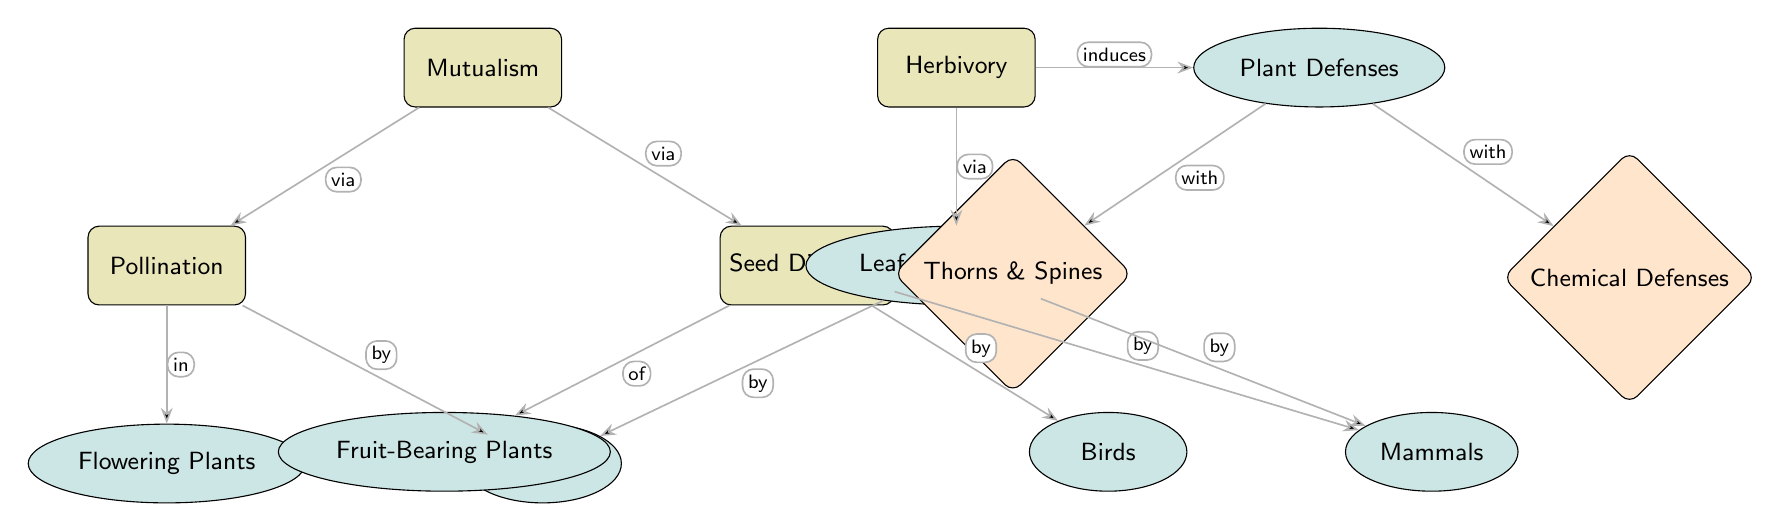what are the main interactions depicted in the diagram? The diagram shows two main interactions: mutualism (pollination and seed dispersal) and herbivory. These are identified as the main nodes at the top level.
Answer: Mutualism and Herbivory how many secondary nodes are there? Counting the secondary nodes, there are six: flowering plants, insects, fruit-bearing plants, birds, mammals, and leaf consumption.
Answer: Six which node is related to both pollination and insects? The node directly related to both pollination and insects is 'flowering plants', which connects pollination with insects in the diagram.
Answer: Flowering Plants what does herbivory induce? The diagram indicates that herbivory induces plant defenses, showing a direct relationship from herbivory to plant defenses.
Answer: Plant Defenses which secondary node is linked to leaf consumption by insects? The secondary node linked to leaf consumption by insects is directly indicated as being leaf consumption, which is part of the herbivory section.
Answer: Leaf Consumption describe the relationship between plant defenses and chemical defenses? The relationship is that plant defenses are applied with chemical defenses, indicating an interactive process where chemical defenses are a form of protection against herbivory.
Answer: With how many edges are connected to the 'seed dispersal' node? The 'seed dispersal' node is connected by three edges: one to fruit-bearing plants and two to birds and mammals, which indicates different forms of seed dispersal.
Answer: Three what type of plant is indirectly associated with insects through pollination? Flowering plants are indirectly associated with insects since they rely on insects for the pollination process as depicted in the diagram.
Answer: Flowering Plants which type of defenses do plants develop to counteract herbivory? To counteract herbivory, plants develop defenses typically categorized into chemical defenses and physical structures like thorns and spines.
Answer: Chemical Defenses and Thorns & Spines 